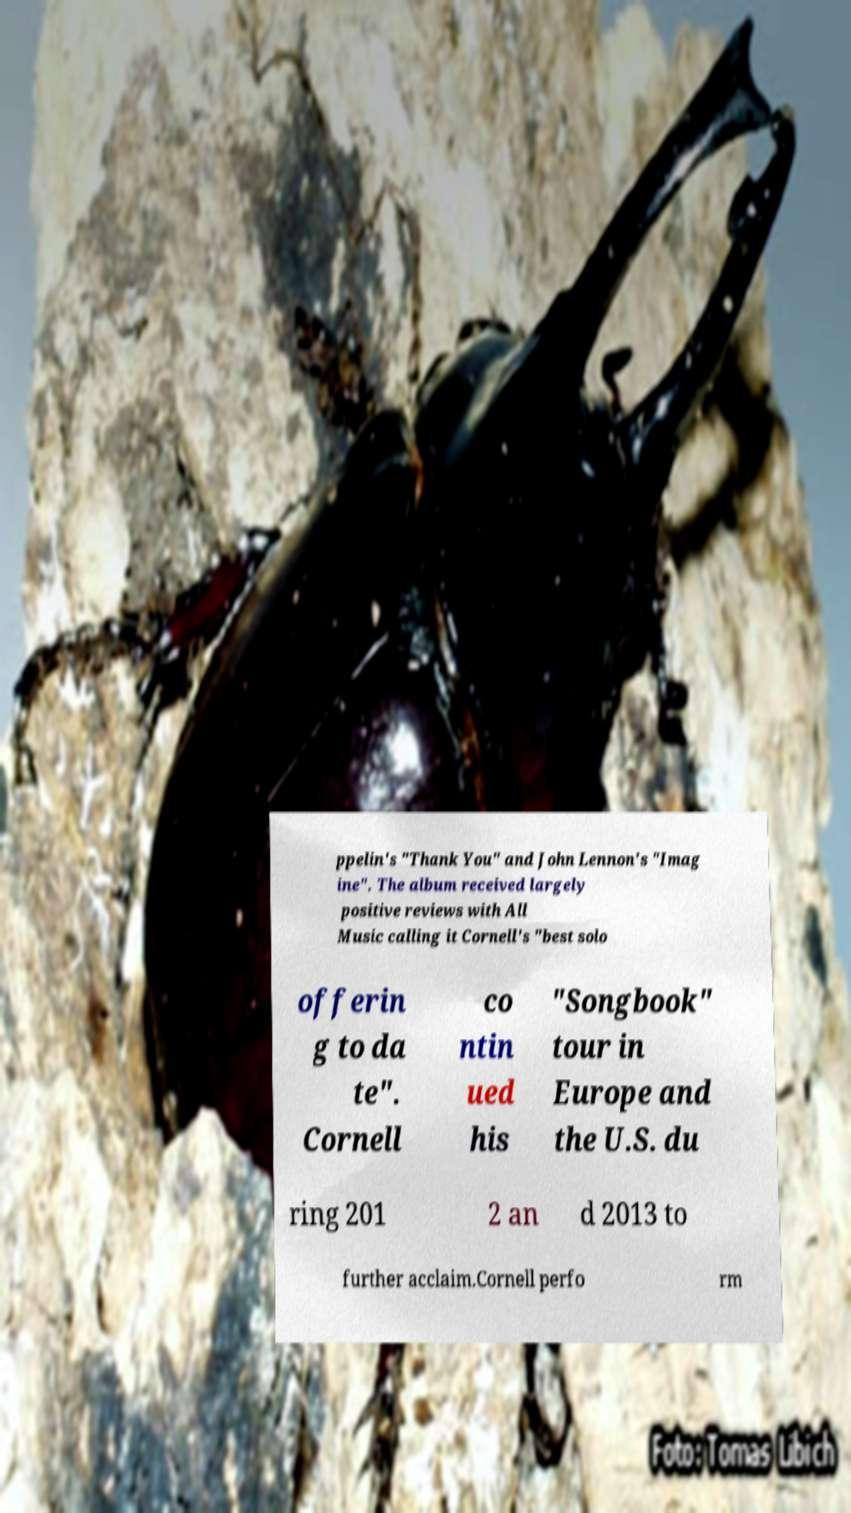There's text embedded in this image that I need extracted. Can you transcribe it verbatim? ppelin's "Thank You" and John Lennon's "Imag ine". The album received largely positive reviews with All Music calling it Cornell's "best solo offerin g to da te". Cornell co ntin ued his "Songbook" tour in Europe and the U.S. du ring 201 2 an d 2013 to further acclaim.Cornell perfo rm 